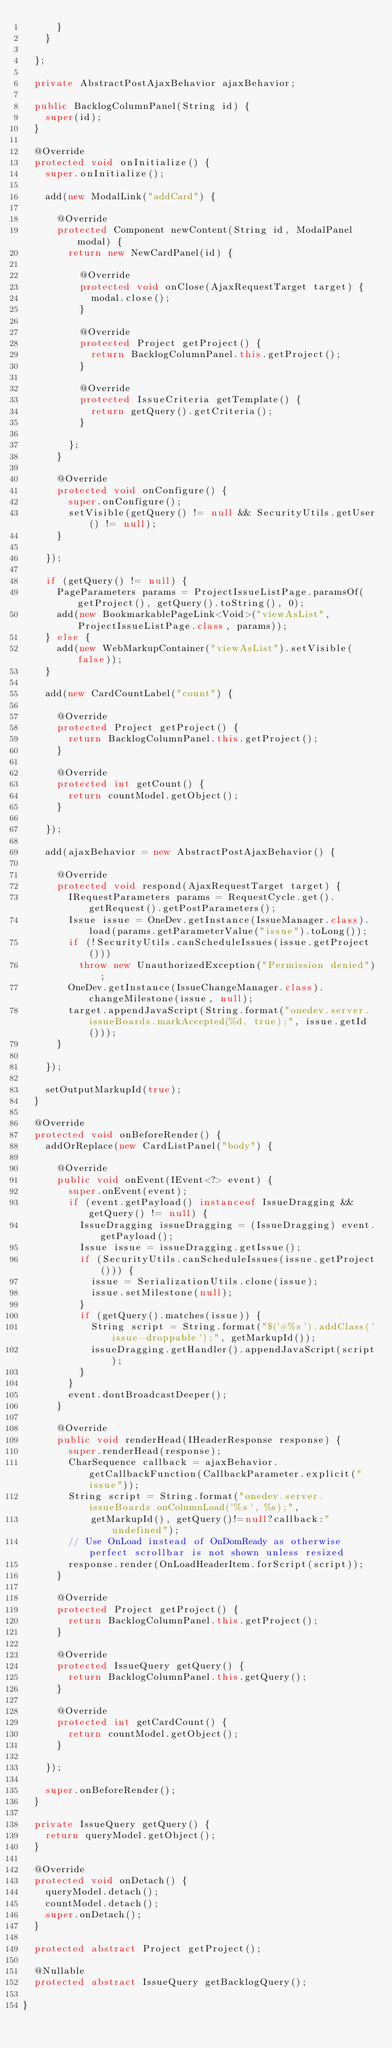Convert code to text. <code><loc_0><loc_0><loc_500><loc_500><_Java_>			}
		}
		
	};
	
	private AbstractPostAjaxBehavior ajaxBehavior;
	
	public BacklogColumnPanel(String id) {
		super(id);
	}

	@Override
	protected void onInitialize() {
		super.onInitialize();

		add(new ModalLink("addCard") {

			@Override
			protected Component newContent(String id, ModalPanel modal) {
				return new NewCardPanel(id) {

					@Override
					protected void onClose(AjaxRequestTarget target) {
						modal.close();
					}

					@Override
					protected Project getProject() {
						return BacklogColumnPanel.this.getProject();
					}

					@Override
					protected IssueCriteria getTemplate() {
						return getQuery().getCriteria();
					}

				};
			}

			@Override
			protected void onConfigure() {
				super.onConfigure();
				setVisible(getQuery() != null && SecurityUtils.getUser() != null);
			}
			
		});
		
		if (getQuery() != null) {
			PageParameters params = ProjectIssueListPage.paramsOf(getProject(), getQuery().toString(), 0);
			add(new BookmarkablePageLink<Void>("viewAsList", ProjectIssueListPage.class, params));
		} else {
			add(new WebMarkupContainer("viewAsList").setVisible(false));
		}
		
		add(new CardCountLabel("count") {

			@Override
			protected Project getProject() {
				return BacklogColumnPanel.this.getProject();
			}

			@Override
			protected int getCount() {
				return countModel.getObject();
			}

		});
		
		add(ajaxBehavior = new AbstractPostAjaxBehavior() {
			
			@Override
			protected void respond(AjaxRequestTarget target) {
				IRequestParameters params = RequestCycle.get().getRequest().getPostParameters();
				Issue issue = OneDev.getInstance(IssueManager.class).load(params.getParameterValue("issue").toLong());
				if (!SecurityUtils.canScheduleIssues(issue.getProject())) 
					throw new UnauthorizedException("Permission denied");
				OneDev.getInstance(IssueChangeManager.class).changeMilestone(issue, null);
				target.appendJavaScript(String.format("onedev.server.issueBoards.markAccepted(%d, true);", issue.getId()));
			}
			
		});
		
		setOutputMarkupId(true);
	}
	
	@Override
	protected void onBeforeRender() {
		addOrReplace(new CardListPanel("body") {

			@Override
			public void onEvent(IEvent<?> event) {
				super.onEvent(event);
				if (event.getPayload() instanceof IssueDragging && getQuery() != null) {
					IssueDragging issueDragging = (IssueDragging) event.getPayload();
					Issue issue = issueDragging.getIssue();
					if (SecurityUtils.canScheduleIssues(issue.getProject())) {
						issue = SerializationUtils.clone(issue);
						issue.setMilestone(null);
					}
					if (getQuery().matches(issue)) {
						String script = String.format("$('#%s').addClass('issue-droppable');", getMarkupId());
						issueDragging.getHandler().appendJavaScript(script);
					}
				}
				event.dontBroadcastDeeper();
			}

			@Override
			public void renderHead(IHeaderResponse response) {
				super.renderHead(response);
				CharSequence callback = ajaxBehavior.getCallbackFunction(CallbackParameter.explicit("issue"));
				String script = String.format("onedev.server.issueBoards.onColumnLoad('%s', %s);", 
						getMarkupId(), getQuery()!=null?callback:"undefined");
				// Use OnLoad instead of OnDomReady as otherwise perfect scrollbar is not shown unless resized 
				response.render(OnLoadHeaderItem.forScript(script));
			}

			@Override
			protected Project getProject() {
				return BacklogColumnPanel.this.getProject();
			}

			@Override
			protected IssueQuery getQuery() {
				return BacklogColumnPanel.this.getQuery();
			}

			@Override
			protected int getCardCount() {
				return countModel.getObject();
			}

		});
		
		super.onBeforeRender();
	}
	
	private IssueQuery getQuery() {
		return queryModel.getObject();
	}

	@Override
	protected void onDetach() {
		queryModel.detach();
		countModel.detach();
		super.onDetach();
	}

	protected abstract Project getProject();
	
	@Nullable
	protected abstract IssueQuery getBacklogQuery();
	
}
</code> 